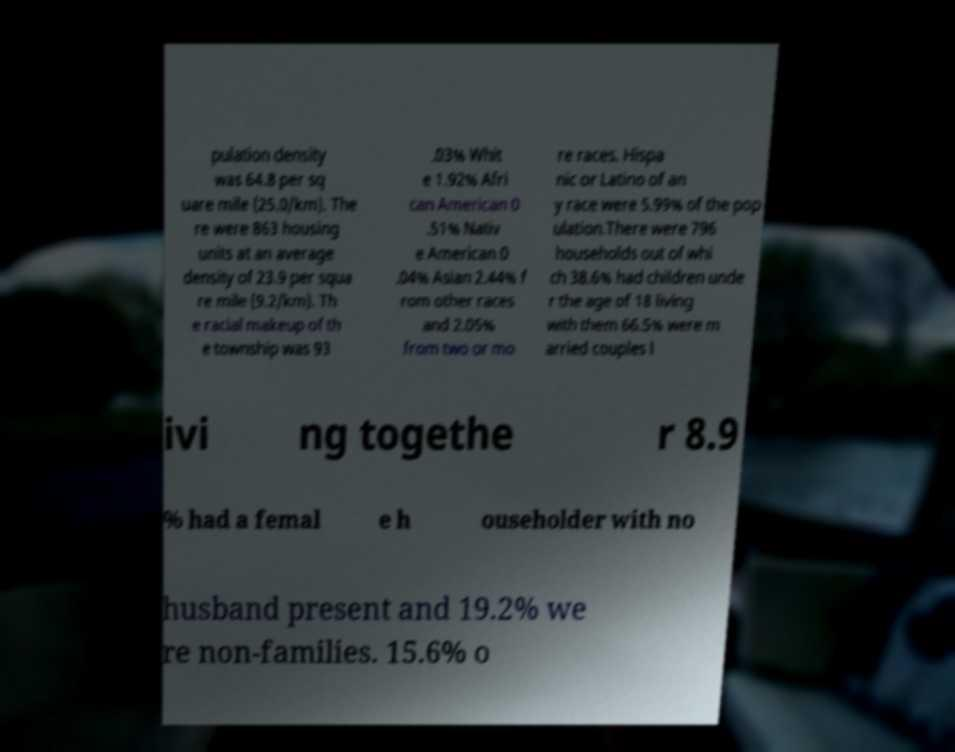For documentation purposes, I need the text within this image transcribed. Could you provide that? pulation density was 64.8 per sq uare mile (25.0/km). The re were 863 housing units at an average density of 23.9 per squa re mile (9.2/km). Th e racial makeup of th e township was 93 .03% Whit e 1.92% Afri can American 0 .51% Nativ e American 0 .04% Asian 2.44% f rom other races and 2.05% from two or mo re races. Hispa nic or Latino of an y race were 5.99% of the pop ulation.There were 796 households out of whi ch 38.6% had children unde r the age of 18 living with them 66.5% were m arried couples l ivi ng togethe r 8.9 % had a femal e h ouseholder with no husband present and 19.2% we re non-families. 15.6% o 